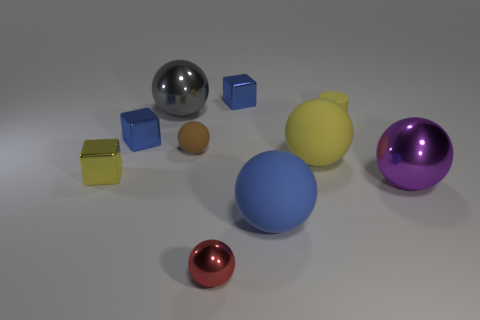Subtract all purple spheres. How many spheres are left? 5 Subtract all large yellow matte spheres. How many spheres are left? 5 Subtract all red balls. Subtract all green cylinders. How many balls are left? 5 Subtract all cubes. How many objects are left? 7 Add 5 red metallic spheres. How many red metallic spheres are left? 6 Add 5 large yellow balls. How many large yellow balls exist? 6 Subtract 1 gray spheres. How many objects are left? 9 Subtract all small brown metal objects. Subtract all red things. How many objects are left? 9 